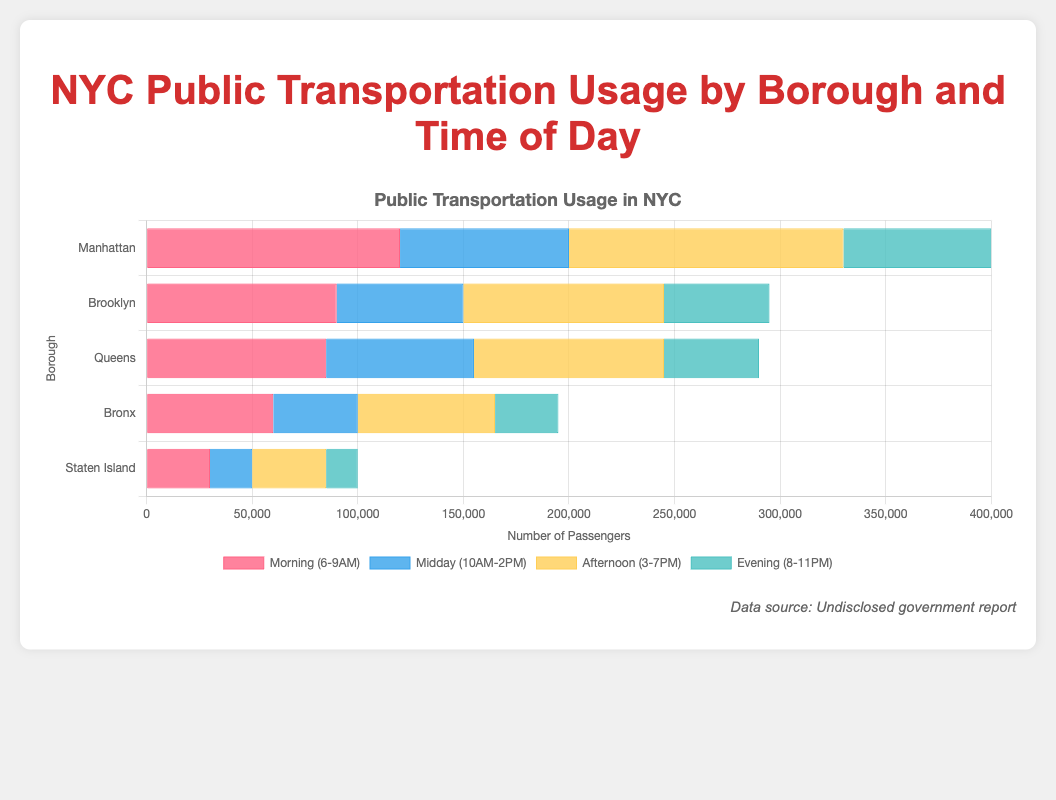How many more passengers use public transportation in Manhattan during the morning (6-9AM) compared to the evening (8-11PM)? To find this, subtract the number of evening passengers in Manhattan from the number of morning passengers: 120,000 - 70,000
Answer: 50,000 Which borough has the highest transportation usage in the afternoon (3-7PM)? Compare the number of passengers for each borough in the afternoon: Manhattan (130,000), Brooklyn (95,000), Queens (90,000), Bronx (65,000), and Staten Island (35,000). The highest is Manhattan with 130,000 passengers.
Answer: Manhattan What is the total number of passengers using public transportation in Queens throughout the day? Sum the number of passengers in Queens for all time periods: 85,000 + 70,000 + 90,000 + 45,000
Answer: 290,000 Which time of day sees the least public transportation usage in Brooklyn? Compare the transportation usage in Brooklyn across all time periods: Morning (90,000), Midday (60,000), Afternoon (95,000), Evening (50,000). The least is in the evening with 50,000 passengers.
Answer: Evening What is the combined total of public transportation users in the Bronx for the periods of Morning (6-9AM) and Afternoon (3-7PM)? Add the number of passengers in the Morning and Afternoon for the Bronx: 60,000 + 65,000
Answer: 125,000 How does the midday (10AM-2PM) public transportation usage in Staten Island compare to that in Queens? Compare the number of passengers at midday in both boroughs: Staten Island (20,000) and Queens (70,000). Queens has more passengers.
Answer: Queens What is the percentage of total daily passengers in Manhattan that use public transportation in the midday (10AM-2PM)? Calculate the total daily passengers in Manhattan: 120,000 + 80,000 + 130,000 + 70,000 = 400,000. Then, find the percentage for the midday: (80,000 / 400,000) * 100
Answer: 20% Which borough has the lowest transportation usage overall throughout the day? Sum all the passengers in each borough and compare: Manhattan (400,000), Brooklyn (295,000), Queens (290,000), Bronx (195,000), Staten Island (100,000). The lowest is Staten Island with 100,000 passengers.
Answer: Staten Island What is the difference in public transportation usage between Manhattan and Brooklyn during the afternoon (3-7PM)? Subtract the number of passengers in Brooklyn from those in Manhattan during the afternoon: 130,000 - 95,000
Answer: 35,000 